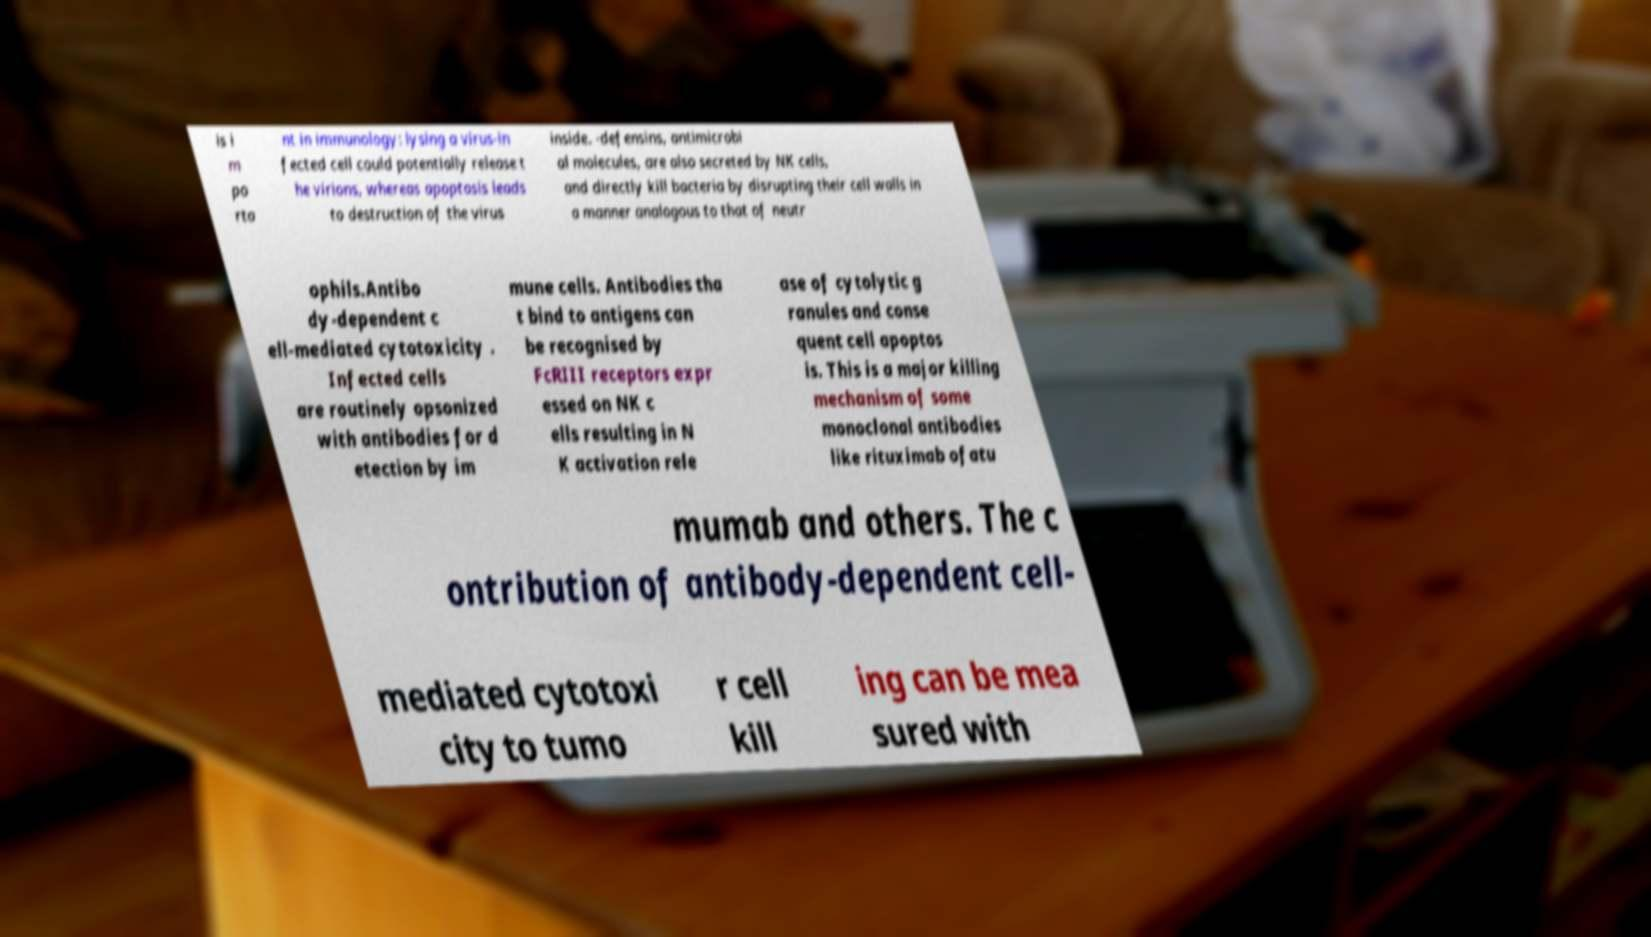Please identify and transcribe the text found in this image. is i m po rta nt in immunology: lysing a virus-in fected cell could potentially release t he virions, whereas apoptosis leads to destruction of the virus inside. -defensins, antimicrobi al molecules, are also secreted by NK cells, and directly kill bacteria by disrupting their cell walls in a manner analogous to that of neutr ophils.Antibo dy-dependent c ell-mediated cytotoxicity . Infected cells are routinely opsonized with antibodies for d etection by im mune cells. Antibodies tha t bind to antigens can be recognised by FcRIII receptors expr essed on NK c ells resulting in N K activation rele ase of cytolytic g ranules and conse quent cell apoptos is. This is a major killing mechanism of some monoclonal antibodies like rituximab ofatu mumab and others. The c ontribution of antibody-dependent cell- mediated cytotoxi city to tumo r cell kill ing can be mea sured with 